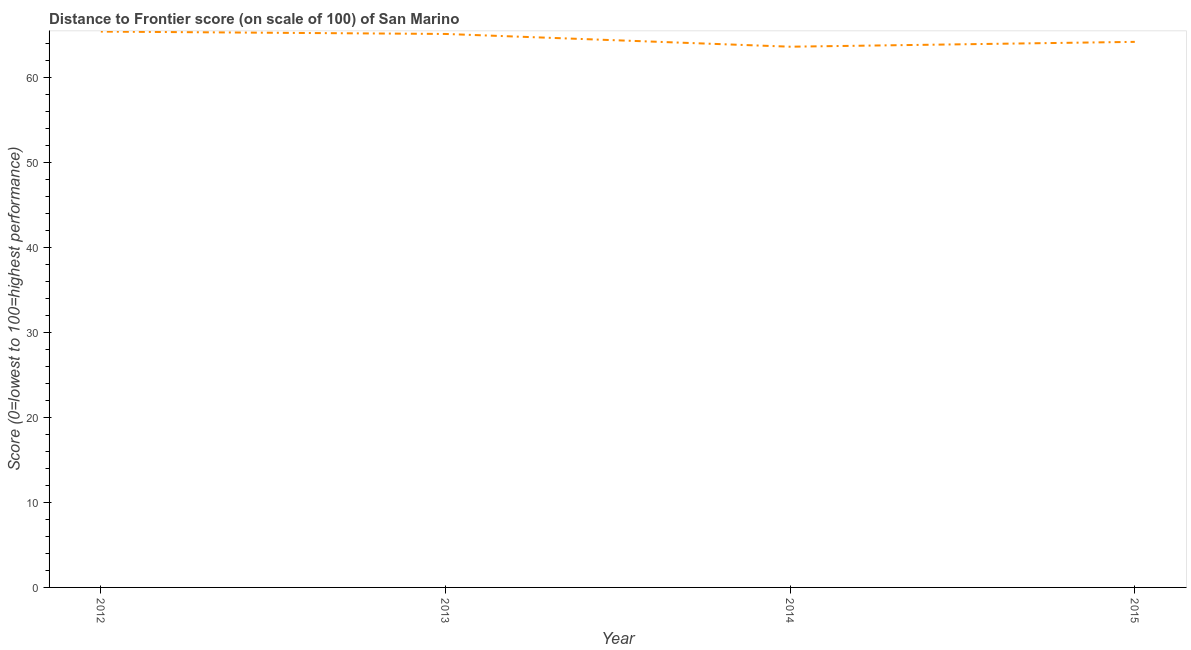What is the distance to frontier score in 2014?
Ensure brevity in your answer.  63.64. Across all years, what is the maximum distance to frontier score?
Give a very brief answer. 65.42. Across all years, what is the minimum distance to frontier score?
Give a very brief answer. 63.64. What is the sum of the distance to frontier score?
Your answer should be very brief. 258.41. What is the difference between the distance to frontier score in 2012 and 2014?
Provide a succinct answer. 1.78. What is the average distance to frontier score per year?
Keep it short and to the point. 64.6. What is the median distance to frontier score?
Give a very brief answer. 64.67. In how many years, is the distance to frontier score greater than 30 ?
Provide a short and direct response. 4. What is the ratio of the distance to frontier score in 2012 to that in 2013?
Offer a very short reply. 1. Is the distance to frontier score in 2012 less than that in 2013?
Your answer should be compact. No. What is the difference between the highest and the second highest distance to frontier score?
Offer a very short reply. 0.28. Is the sum of the distance to frontier score in 2013 and 2014 greater than the maximum distance to frontier score across all years?
Give a very brief answer. Yes. What is the difference between the highest and the lowest distance to frontier score?
Your answer should be very brief. 1.78. In how many years, is the distance to frontier score greater than the average distance to frontier score taken over all years?
Your answer should be very brief. 2. Does the distance to frontier score monotonically increase over the years?
Make the answer very short. No. How many years are there in the graph?
Offer a very short reply. 4. Does the graph contain any zero values?
Your answer should be very brief. No. What is the title of the graph?
Provide a succinct answer. Distance to Frontier score (on scale of 100) of San Marino. What is the label or title of the Y-axis?
Provide a succinct answer. Score (0=lowest to 100=highest performance). What is the Score (0=lowest to 100=highest performance) of 2012?
Keep it short and to the point. 65.42. What is the Score (0=lowest to 100=highest performance) in 2013?
Make the answer very short. 65.14. What is the Score (0=lowest to 100=highest performance) in 2014?
Your answer should be compact. 63.64. What is the Score (0=lowest to 100=highest performance) of 2015?
Offer a terse response. 64.21. What is the difference between the Score (0=lowest to 100=highest performance) in 2012 and 2013?
Keep it short and to the point. 0.28. What is the difference between the Score (0=lowest to 100=highest performance) in 2012 and 2014?
Offer a terse response. 1.78. What is the difference between the Score (0=lowest to 100=highest performance) in 2012 and 2015?
Give a very brief answer. 1.21. What is the difference between the Score (0=lowest to 100=highest performance) in 2013 and 2014?
Your answer should be compact. 1.5. What is the difference between the Score (0=lowest to 100=highest performance) in 2014 and 2015?
Provide a short and direct response. -0.57. What is the ratio of the Score (0=lowest to 100=highest performance) in 2012 to that in 2014?
Ensure brevity in your answer.  1.03. What is the ratio of the Score (0=lowest to 100=highest performance) in 2012 to that in 2015?
Keep it short and to the point. 1.02. What is the ratio of the Score (0=lowest to 100=highest performance) in 2013 to that in 2014?
Your answer should be very brief. 1.02. What is the ratio of the Score (0=lowest to 100=highest performance) in 2014 to that in 2015?
Provide a succinct answer. 0.99. 